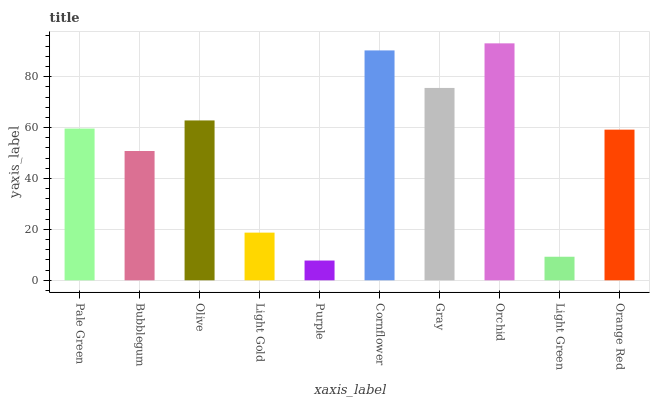Is Bubblegum the minimum?
Answer yes or no. No. Is Bubblegum the maximum?
Answer yes or no. No. Is Pale Green greater than Bubblegum?
Answer yes or no. Yes. Is Bubblegum less than Pale Green?
Answer yes or no. Yes. Is Bubblegum greater than Pale Green?
Answer yes or no. No. Is Pale Green less than Bubblegum?
Answer yes or no. No. Is Pale Green the high median?
Answer yes or no. Yes. Is Orange Red the low median?
Answer yes or no. Yes. Is Olive the high median?
Answer yes or no. No. Is Gray the low median?
Answer yes or no. No. 